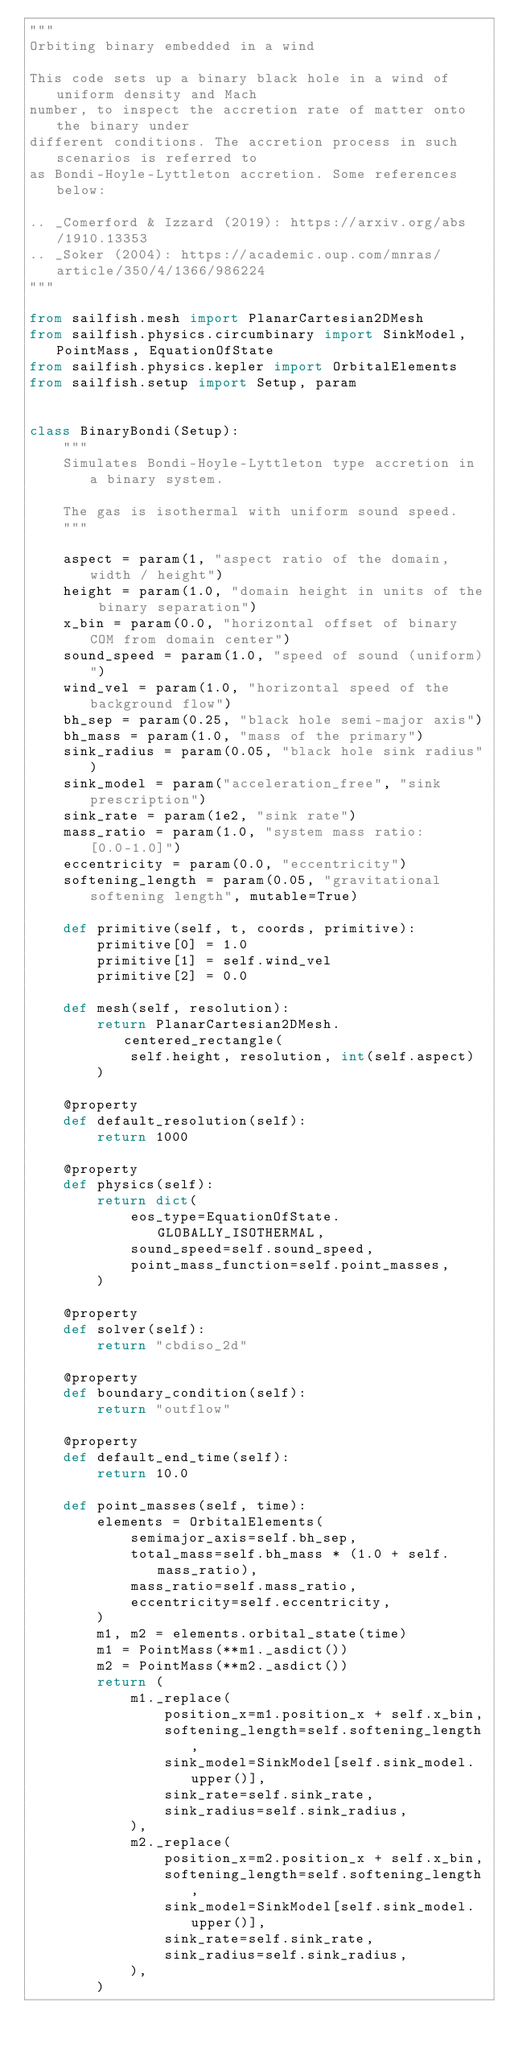<code> <loc_0><loc_0><loc_500><loc_500><_Python_>"""
Orbiting binary embedded in a wind

This code sets up a binary black hole in a wind of uniform density and Mach
number, to inspect the accretion rate of matter onto the binary under
different conditions. The accretion process in such scenarios is referred to
as Bondi-Hoyle-Lyttleton accretion. Some references below:

.. _Comerford & Izzard (2019): https://arxiv.org/abs/1910.13353
.. _Soker (2004): https://academic.oup.com/mnras/article/350/4/1366/986224
"""

from sailfish.mesh import PlanarCartesian2DMesh
from sailfish.physics.circumbinary import SinkModel, PointMass, EquationOfState
from sailfish.physics.kepler import OrbitalElements
from sailfish.setup import Setup, param


class BinaryBondi(Setup):
    """
    Simulates Bondi-Hoyle-Lyttleton type accretion in a binary system.

    The gas is isothermal with uniform sound speed.
    """

    aspect = param(1, "aspect ratio of the domain, width / height")
    height = param(1.0, "domain height in units of the binary separation")
    x_bin = param(0.0, "horizontal offset of binary COM from domain center")
    sound_speed = param(1.0, "speed of sound (uniform)")
    wind_vel = param(1.0, "horizontal speed of the background flow")
    bh_sep = param(0.25, "black hole semi-major axis")
    bh_mass = param(1.0, "mass of the primary")
    sink_radius = param(0.05, "black hole sink radius")
    sink_model = param("acceleration_free", "sink prescription")
    sink_rate = param(1e2, "sink rate")
    mass_ratio = param(1.0, "system mass ratio: [0.0-1.0]")
    eccentricity = param(0.0, "eccentricity")
    softening_length = param(0.05, "gravitational softening length", mutable=True)

    def primitive(self, t, coords, primitive):
        primitive[0] = 1.0
        primitive[1] = self.wind_vel
        primitive[2] = 0.0

    def mesh(self, resolution):
        return PlanarCartesian2DMesh.centered_rectangle(
            self.height, resolution, int(self.aspect)
        )

    @property
    def default_resolution(self):
        return 1000

    @property
    def physics(self):
        return dict(
            eos_type=EquationOfState.GLOBALLY_ISOTHERMAL,
            sound_speed=self.sound_speed,
            point_mass_function=self.point_masses,
        )

    @property
    def solver(self):
        return "cbdiso_2d"

    @property
    def boundary_condition(self):
        return "outflow"

    @property
    def default_end_time(self):
        return 10.0

    def point_masses(self, time):
        elements = OrbitalElements(
            semimajor_axis=self.bh_sep,
            total_mass=self.bh_mass * (1.0 + self.mass_ratio),
            mass_ratio=self.mass_ratio,
            eccentricity=self.eccentricity,
        )
        m1, m2 = elements.orbital_state(time)
        m1 = PointMass(**m1._asdict())
        m2 = PointMass(**m2._asdict())
        return (
            m1._replace(
                position_x=m1.position_x + self.x_bin,
                softening_length=self.softening_length,
                sink_model=SinkModel[self.sink_model.upper()],
                sink_rate=self.sink_rate,
                sink_radius=self.sink_radius,
            ),
            m2._replace(
                position_x=m2.position_x + self.x_bin,
                softening_length=self.softening_length,
                sink_model=SinkModel[self.sink_model.upper()],
                sink_rate=self.sink_rate,
                sink_radius=self.sink_radius,
            ),
        )
</code> 